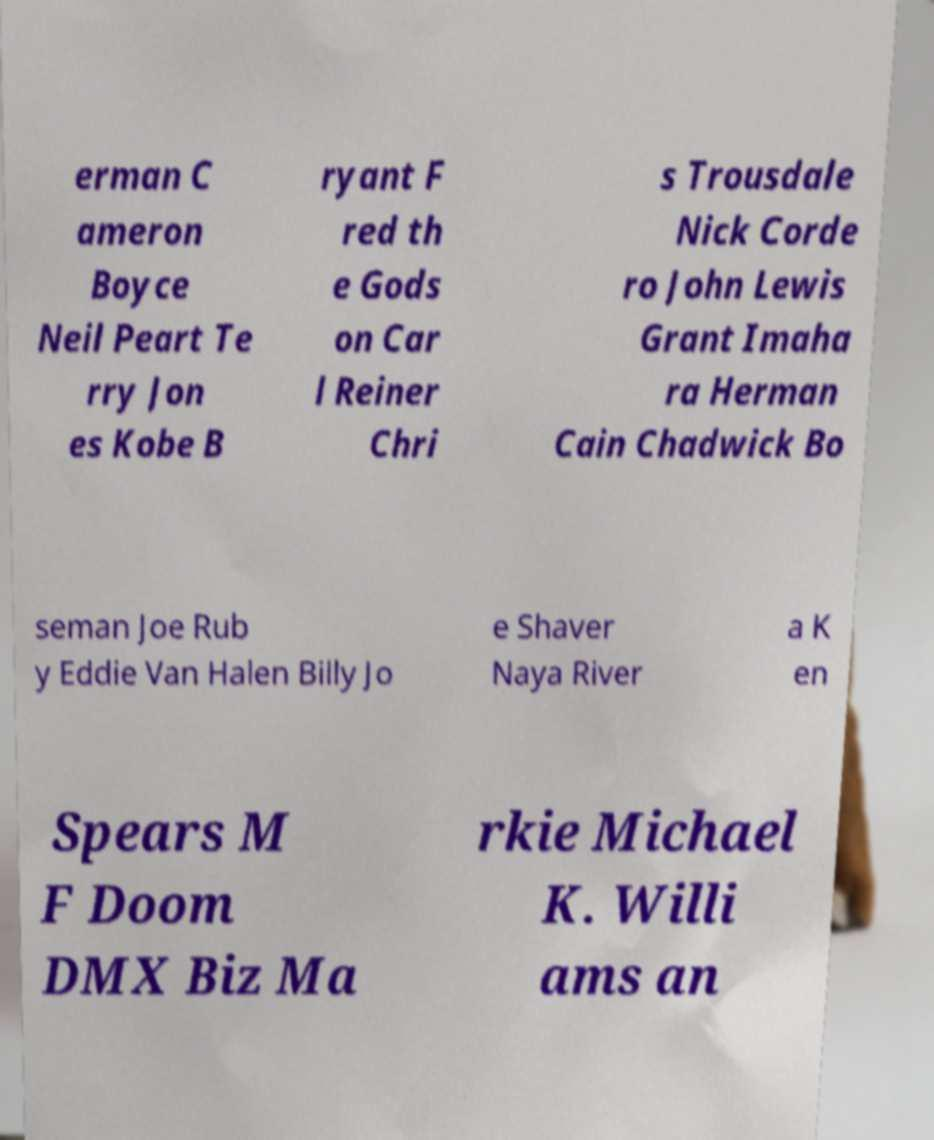For documentation purposes, I need the text within this image transcribed. Could you provide that? erman C ameron Boyce Neil Peart Te rry Jon es Kobe B ryant F red th e Gods on Car l Reiner Chri s Trousdale Nick Corde ro John Lewis Grant Imaha ra Herman Cain Chadwick Bo seman Joe Rub y Eddie Van Halen Billy Jo e Shaver Naya River a K en Spears M F Doom DMX Biz Ma rkie Michael K. Willi ams an 